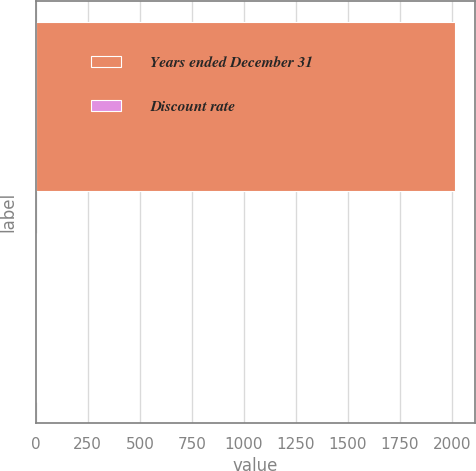Convert chart to OTSL. <chart><loc_0><loc_0><loc_500><loc_500><bar_chart><fcel>Years ended December 31<fcel>Discount rate<nl><fcel>2012<fcel>5<nl></chart> 